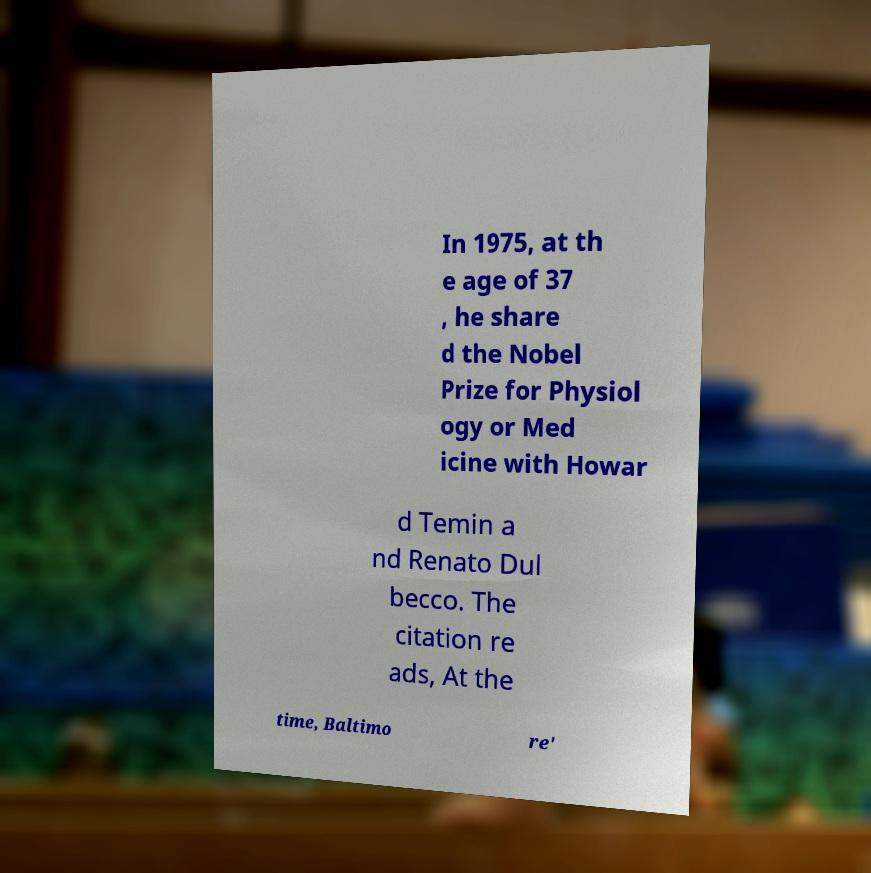For documentation purposes, I need the text within this image transcribed. Could you provide that? In 1975, at th e age of 37 , he share d the Nobel Prize for Physiol ogy or Med icine with Howar d Temin a nd Renato Dul becco. The citation re ads, At the time, Baltimo re' 